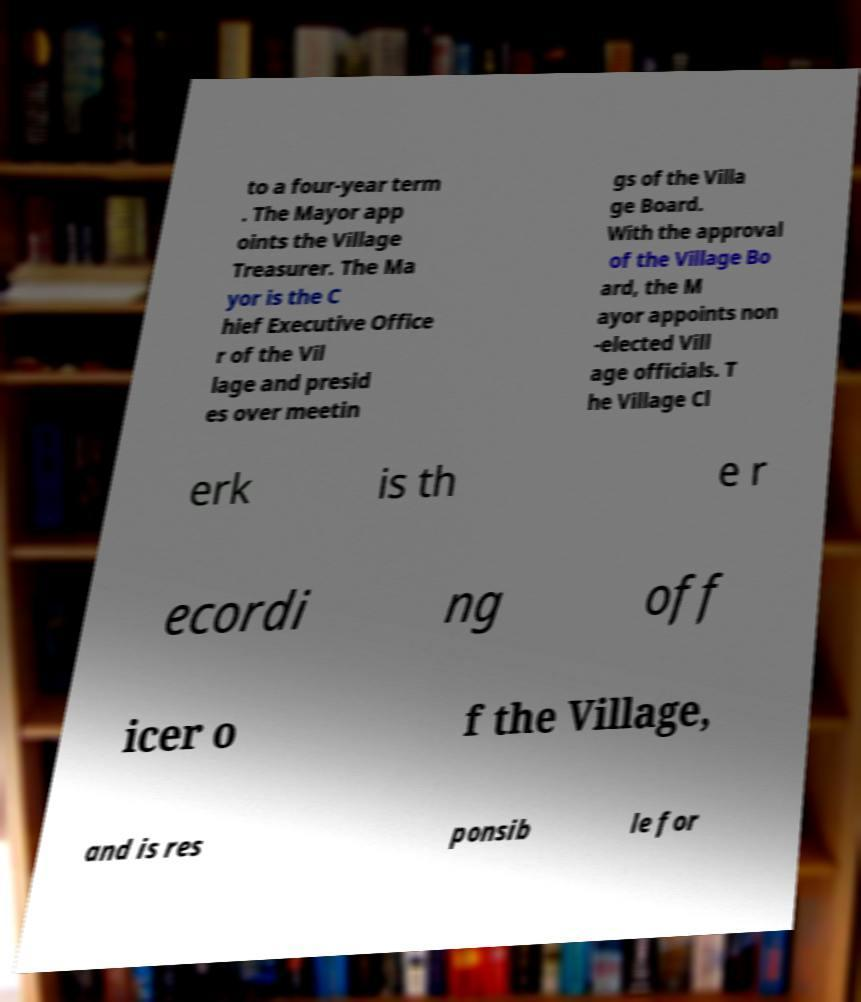Can you accurately transcribe the text from the provided image for me? to a four-year term . The Mayor app oints the Village Treasurer. The Ma yor is the C hief Executive Office r of the Vil lage and presid es over meetin gs of the Villa ge Board. With the approval of the Village Bo ard, the M ayor appoints non -elected Vill age officials. T he Village Cl erk is th e r ecordi ng off icer o f the Village, and is res ponsib le for 